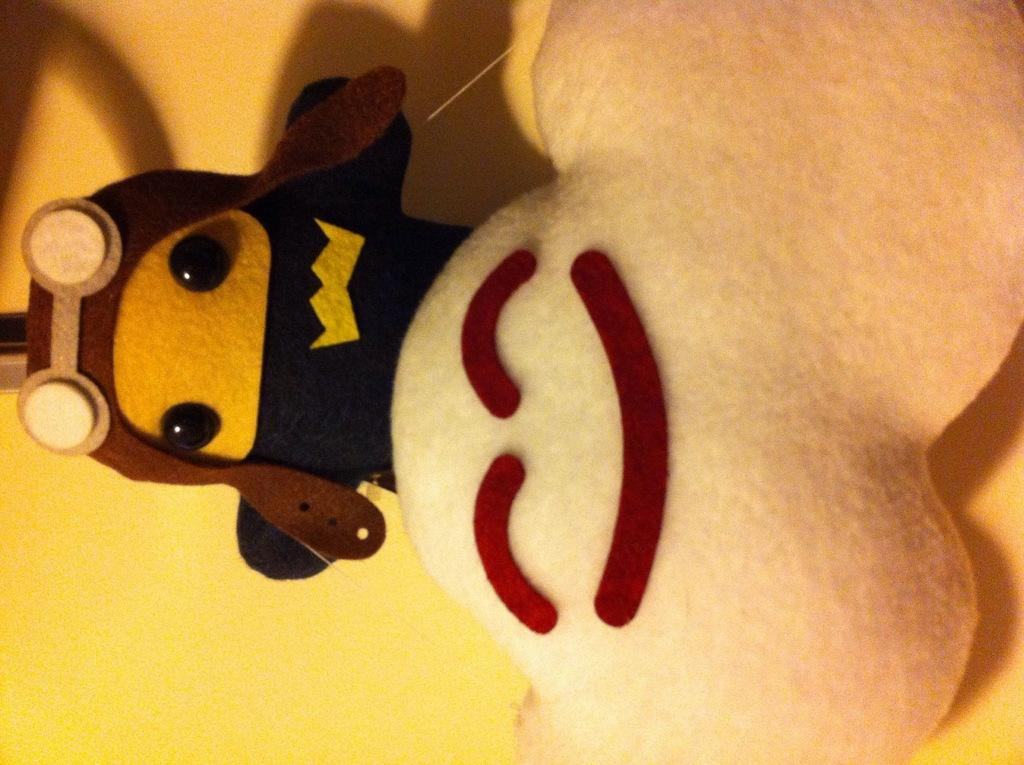How many toys can be seen in the image? There are two toys in the image. What can be observed on the yellow surface in the image? Shadows are visible on the yellow surface in the image. What type of sleet is falling on the toys in the image? There is no sleet present in the image; it is a dry environment with shadows on a yellow surface. 